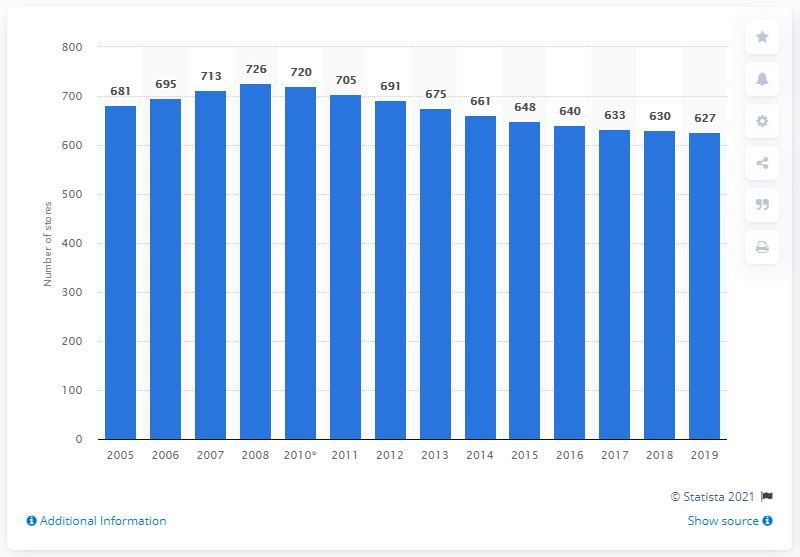Indicate a few pertinent items in this graphic. Barnes & Noble had 627 stores in the United States in 2019. Barnes & Noble had 726 stores in the United States in 2008. 